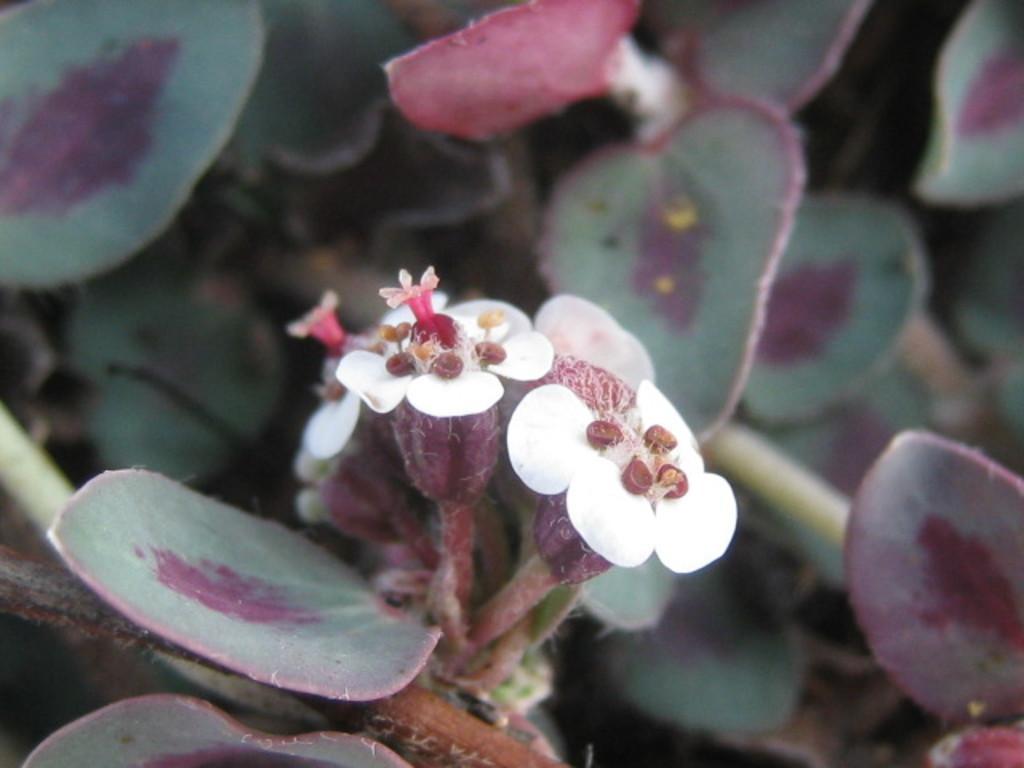How would you summarize this image in a sentence or two? in this image there is a flower in middle of this image which is in white and pink color and there are some leaves in the background. 